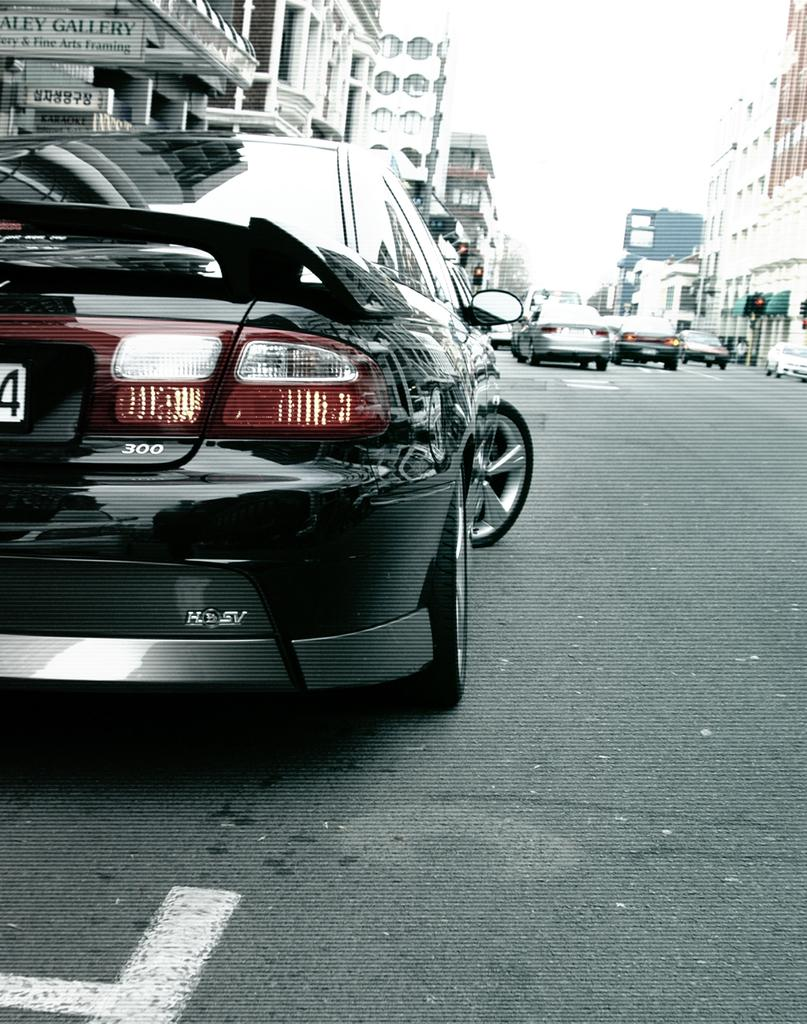What type of vehicle is on the road in the image? There is a black color vehicle on the road. What can be seen on both sides of the road? There are buildings on both sides of the road. What is visible in the background of the image? The sky is visible in the background. How many stitches are required to repair the vehicle's tire in the image? There is no indication of a damaged tire or any repair work in the image, so it is not possible to determine the number of stitches required. 